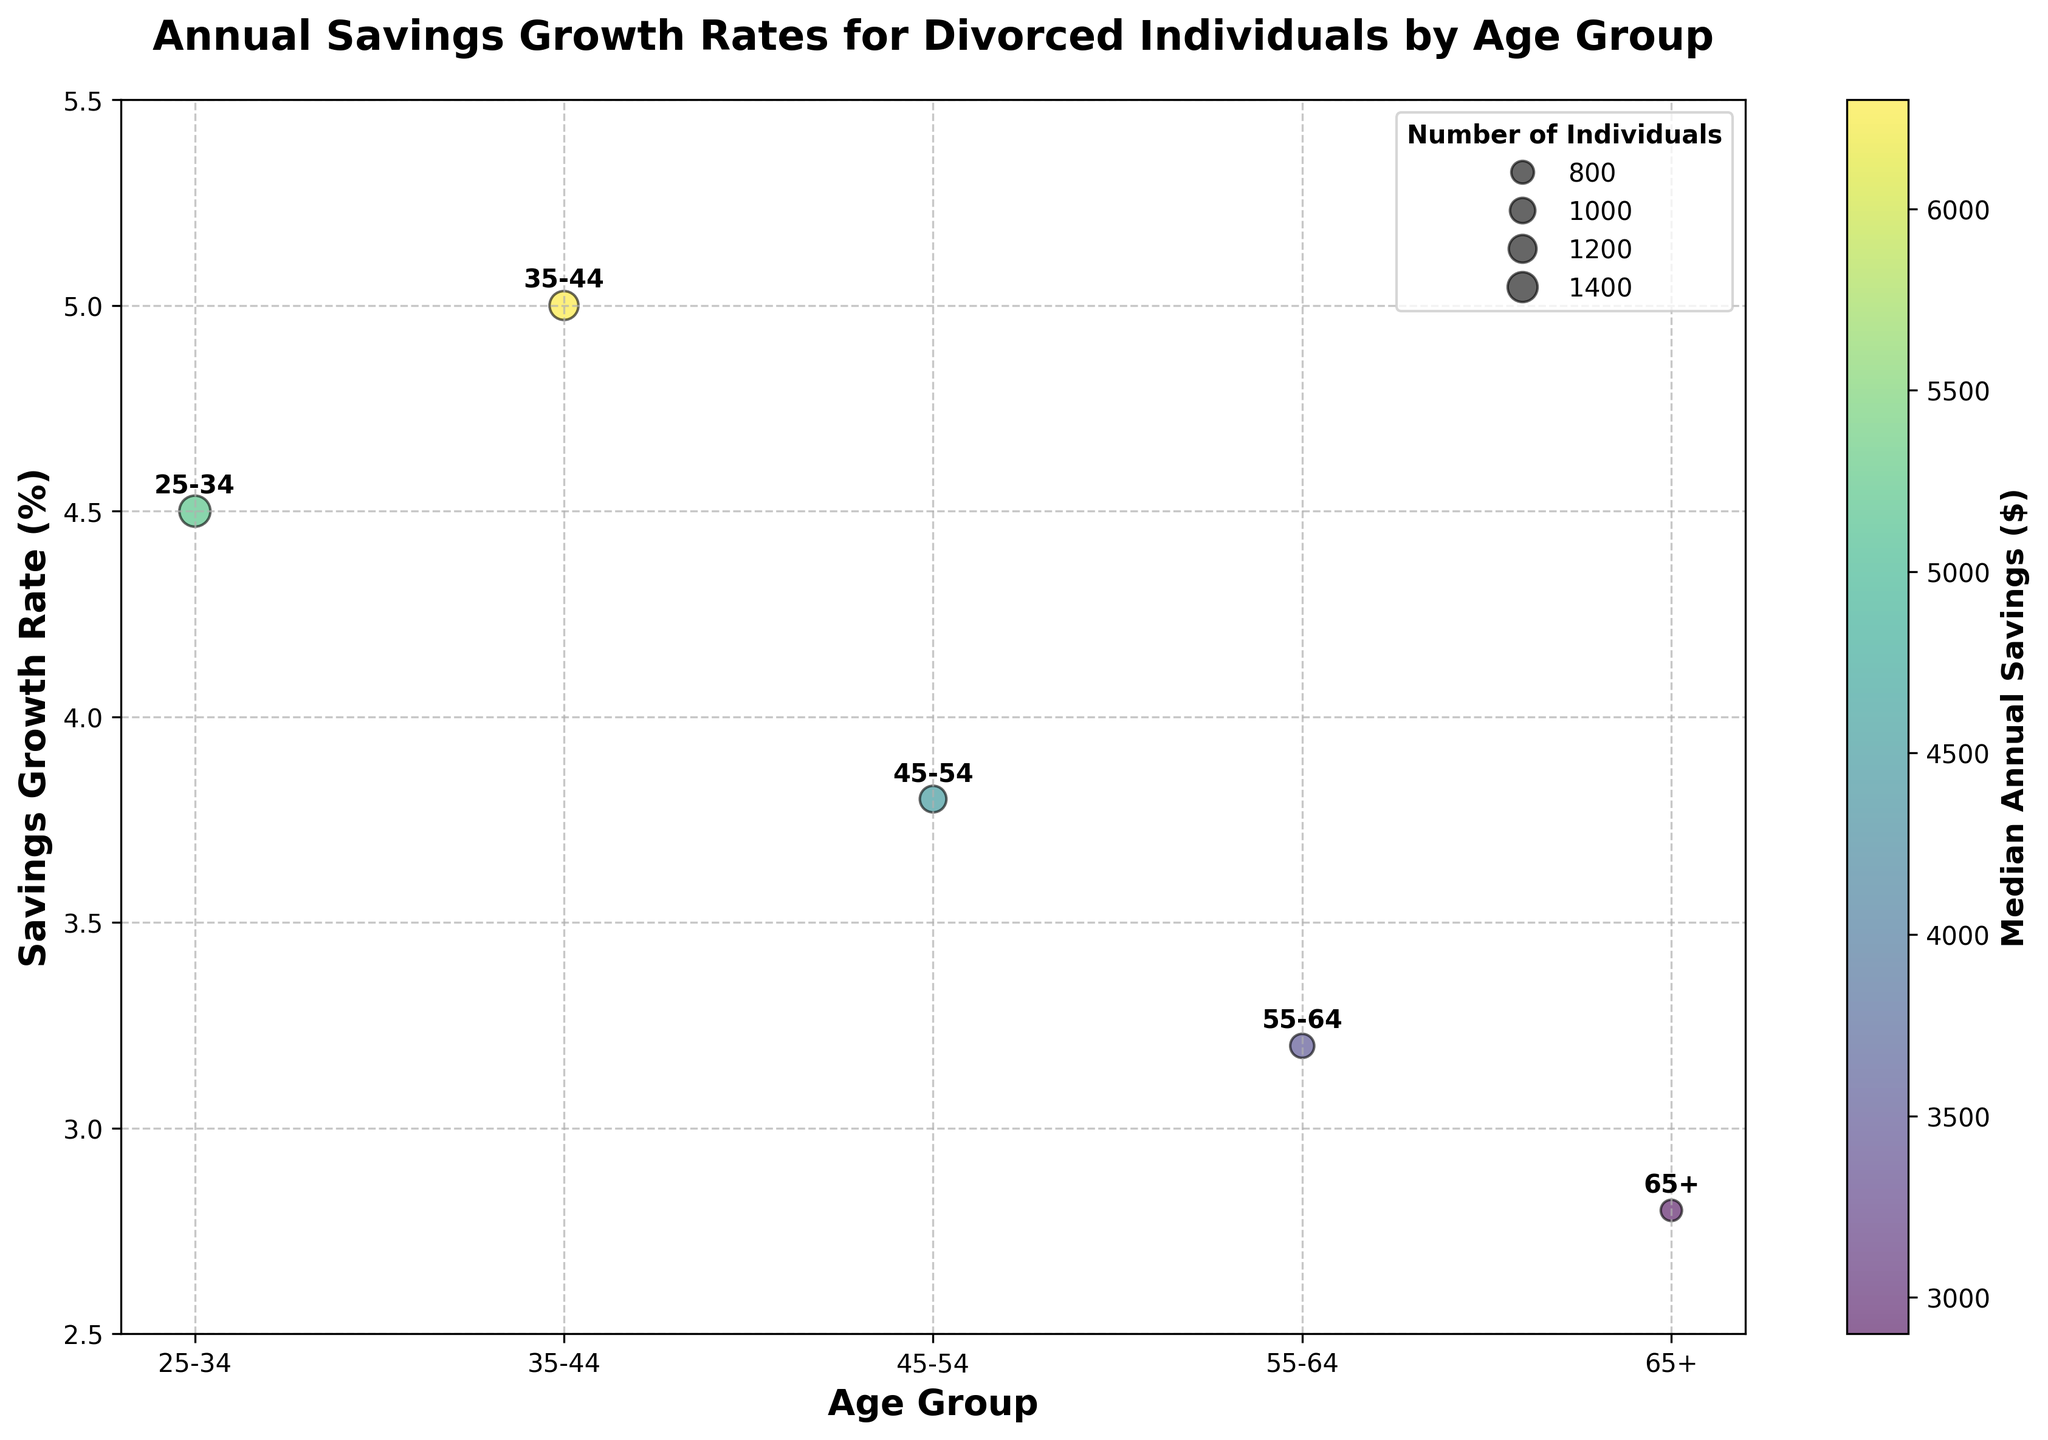What's the title of the chart? The title is prominently displayed at the top of the chart and states the main focus. It reads "Annual Savings Growth Rates for Divorced Individuals by Age Group."
Answer: Annual Savings Growth Rates for Divorced Individuals by Age Group Which age group has the lowest median annual savings? The median annual savings are color-coded on the chart. By looking at the color bar and the color of the bubbles, we can determine that the 65+ age group has the lowest median annual savings ($2,900).
Answer: 65+ What is the savings growth rate for the 35-44 age group? By locating the 35-44 age group on the x-axis and looking at its corresponding position on the y-axis, we see that its savings growth rate is 5.0%.
Answer: 5.0% Which age group has the largest number of individuals? The size of the bubbles indicates the number of individuals. The largest bubble corresponds to the 25-34 age group.
Answer: 25-34 How does the savings growth rate of the 45-54 age group compare with the 55-64 age group? Checking the positions on the y-axis, the 45-54 group has a savings growth rate of 3.8%, while the 55-64 group has a rate of 3.2%. Thus, the 45-54 group has a higher growth rate.
Answer: 45-54 > 55-64 What is the combined total number of individuals for the 55-64 and 65+ age groups? The number of individuals for the 55-64 age group is 900 and for the 65+ age group is 700. Adding them together gives 900 + 700 = 1600 individuals.
Answer: 1600 Which age group has the highest median annual savings and what is it? By examining the color of the bubbles and referring to the color bar, the 35-44 age group has the highest median annual savings, which is $6,300.
Answer: 35-44, $6,300 Within which age group do you see the largest bubble? The size of the bubble represents the number of individuals. The largest bubble is found in the 25-34 age group, indicating the highest number of individuals.
Answer: 25-34 Does any age group have a savings growth rate of more than 5%? By looking at the y-axis and the heights of the bubbles, none of the bubbles (age groups) cross the 5% mark. The closest is the 35-44 age group with a 5.0% growth rate, but it does not exceed 5%.
Answer: No How is the age group labeled on the chart? The x-axis has labels that identify each age group, which are "25-34", "35-44", "45-54", "55-64", and "65+" distinctly marked under each corresponding bubble.
Answer: 25-34, 35-44, 45-54, 55-64, 65+ 